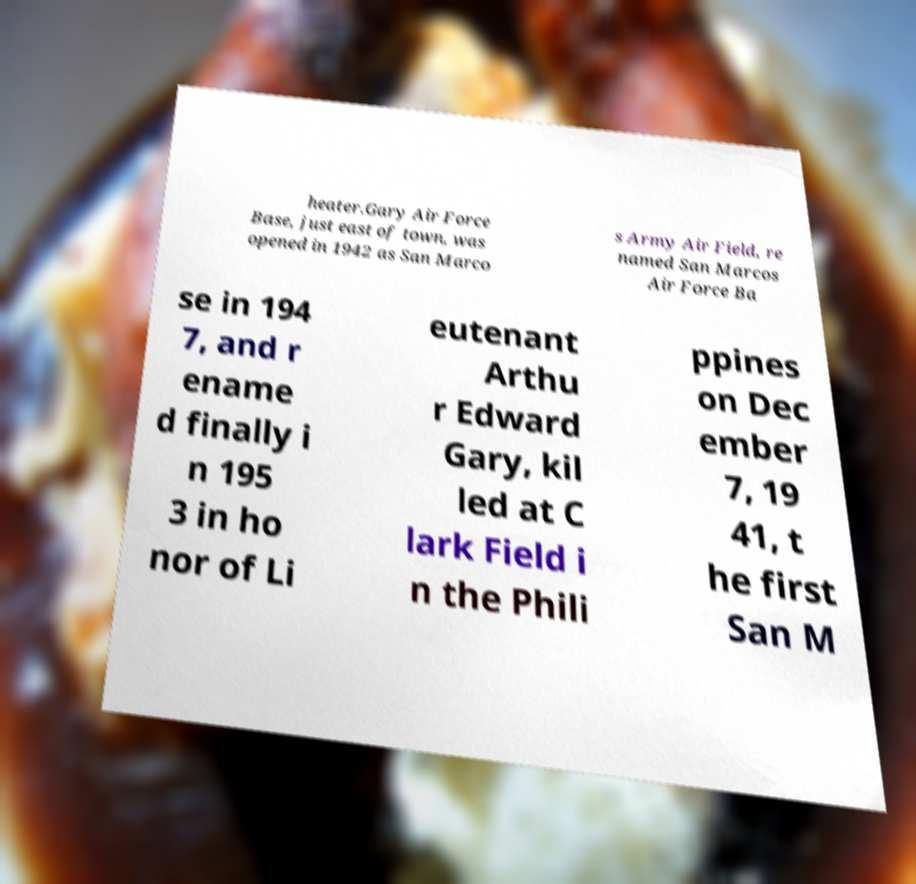Please identify and transcribe the text found in this image. heater.Gary Air Force Base, just east of town, was opened in 1942 as San Marco s Army Air Field, re named San Marcos Air Force Ba se in 194 7, and r ename d finally i n 195 3 in ho nor of Li eutenant Arthu r Edward Gary, kil led at C lark Field i n the Phili ppines on Dec ember 7, 19 41, t he first San M 